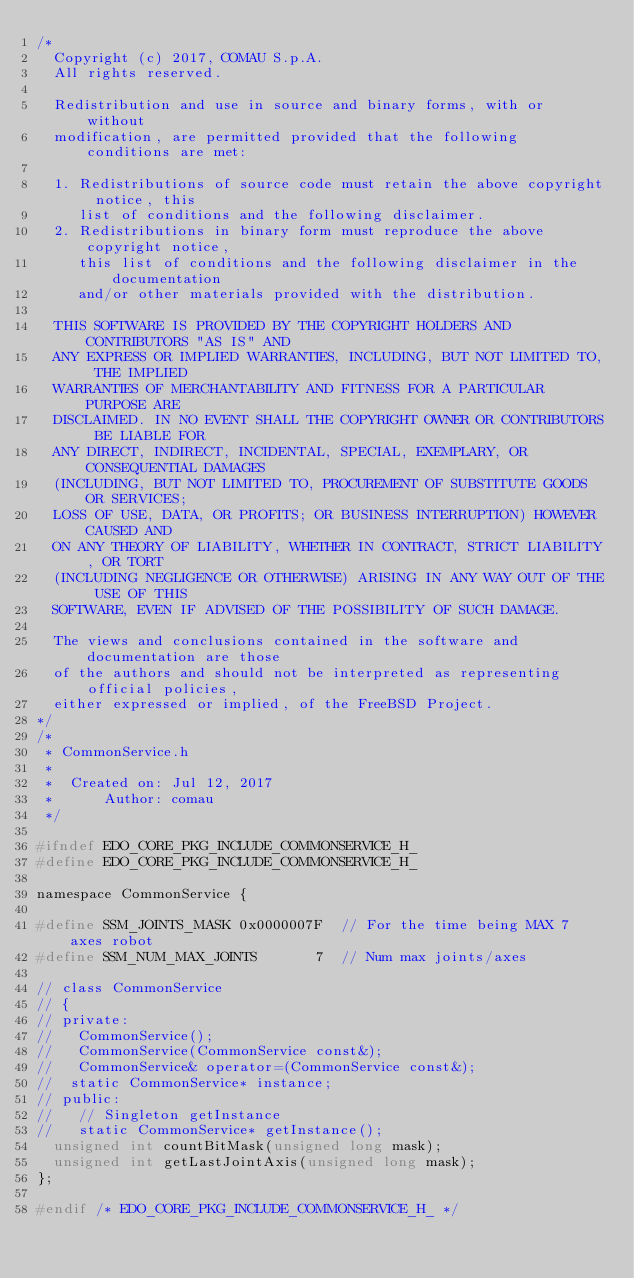<code> <loc_0><loc_0><loc_500><loc_500><_C_>/*
  Copyright (c) 2017, COMAU S.p.A.
  All rights reserved.
  
  Redistribution and use in source and binary forms, with or without
  modification, are permitted provided that the following conditions are met:
  
  1. Redistributions of source code must retain the above copyright notice, this
     list of conditions and the following disclaimer.
  2. Redistributions in binary form must reproduce the above copyright notice,
     this list of conditions and the following disclaimer in the documentation
     and/or other materials provided with the distribution.
  
  THIS SOFTWARE IS PROVIDED BY THE COPYRIGHT HOLDERS AND CONTRIBUTORS "AS IS" AND
  ANY EXPRESS OR IMPLIED WARRANTIES, INCLUDING, BUT NOT LIMITED TO, THE IMPLIED
  WARRANTIES OF MERCHANTABILITY AND FITNESS FOR A PARTICULAR PURPOSE ARE
  DISCLAIMED. IN NO EVENT SHALL THE COPYRIGHT OWNER OR CONTRIBUTORS BE LIABLE FOR
  ANY DIRECT, INDIRECT, INCIDENTAL, SPECIAL, EXEMPLARY, OR CONSEQUENTIAL DAMAGES
  (INCLUDING, BUT NOT LIMITED TO, PROCUREMENT OF SUBSTITUTE GOODS OR SERVICES;
  LOSS OF USE, DATA, OR PROFITS; OR BUSINESS INTERRUPTION) HOWEVER CAUSED AND
  ON ANY THEORY OF LIABILITY, WHETHER IN CONTRACT, STRICT LIABILITY, OR TORT
  (INCLUDING NEGLIGENCE OR OTHERWISE) ARISING IN ANY WAY OUT OF THE USE OF THIS
  SOFTWARE, EVEN IF ADVISED OF THE POSSIBILITY OF SUCH DAMAGE.
  
  The views and conclusions contained in the software and documentation are those
  of the authors and should not be interpreted as representing official policies,
  either expressed or implied, of the FreeBSD Project.
*/
/*
 * CommonService.h
 *
 *  Created on: Jul 12, 2017
 *      Author: comau
 */

#ifndef EDO_CORE_PKG_INCLUDE_COMMONSERVICE_H_
#define EDO_CORE_PKG_INCLUDE_COMMONSERVICE_H_

namespace CommonService {

#define SSM_JOINTS_MASK 0x0000007F  // For the time being MAX 7 axes robot
#define SSM_NUM_MAX_JOINTS       7  // Num max joints/axes

// class CommonService
// {
// private:
//   CommonService();
//   CommonService(CommonService const&);
//   CommonService& operator=(CommonService const&);
// 	static CommonService* instance;
// public:
//   // Singleton getInstance
//   static CommonService* getInstance();
  unsigned int countBitMask(unsigned long mask);
  unsigned int getLastJointAxis(unsigned long mask);
};

#endif /* EDO_CORE_PKG_INCLUDE_COMMONSERVICE_H_ */
</code> 